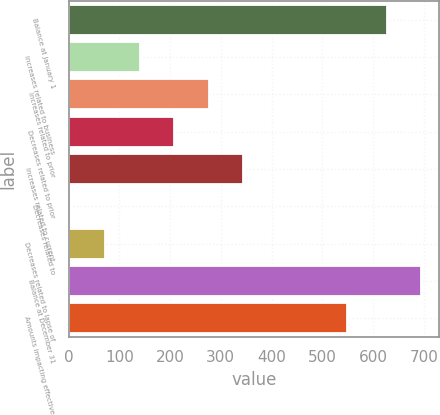<chart> <loc_0><loc_0><loc_500><loc_500><bar_chart><fcel>Balance at January 1<fcel>Increases related to business<fcel>Increases related to prior<fcel>Decreases related to prior<fcel>Increases related to current<fcel>Decreases related to<fcel>Decreases related to lapse of<fcel>Balance at December 31<fcel>Amounts impacting effective<nl><fcel>626.8<fcel>140.14<fcel>276.48<fcel>208.31<fcel>344.65<fcel>3.8<fcel>71.97<fcel>694.97<fcel>549.1<nl></chart> 